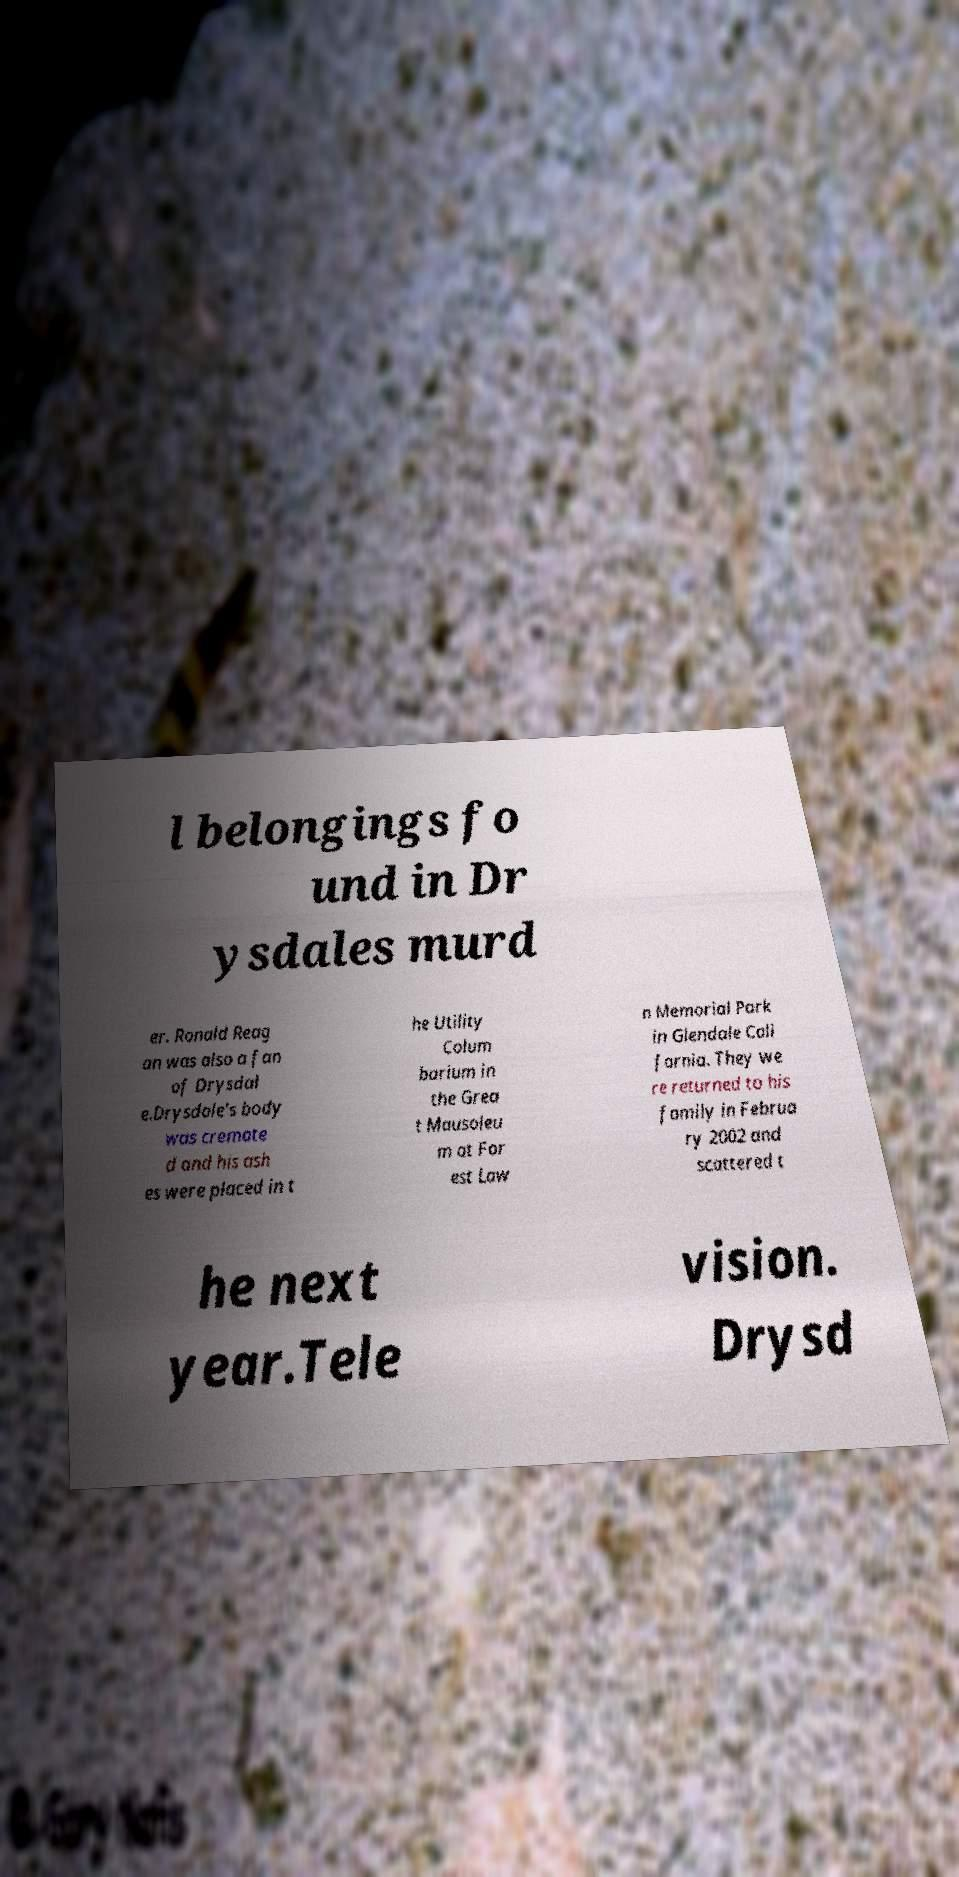Can you read and provide the text displayed in the image?This photo seems to have some interesting text. Can you extract and type it out for me? l belongings fo und in Dr ysdales murd er. Ronald Reag an was also a fan of Drysdal e.Drysdale's body was cremate d and his ash es were placed in t he Utility Colum barium in the Grea t Mausoleu m at For est Law n Memorial Park in Glendale Cali fornia. They we re returned to his family in Februa ry 2002 and scattered t he next year.Tele vision. Drysd 